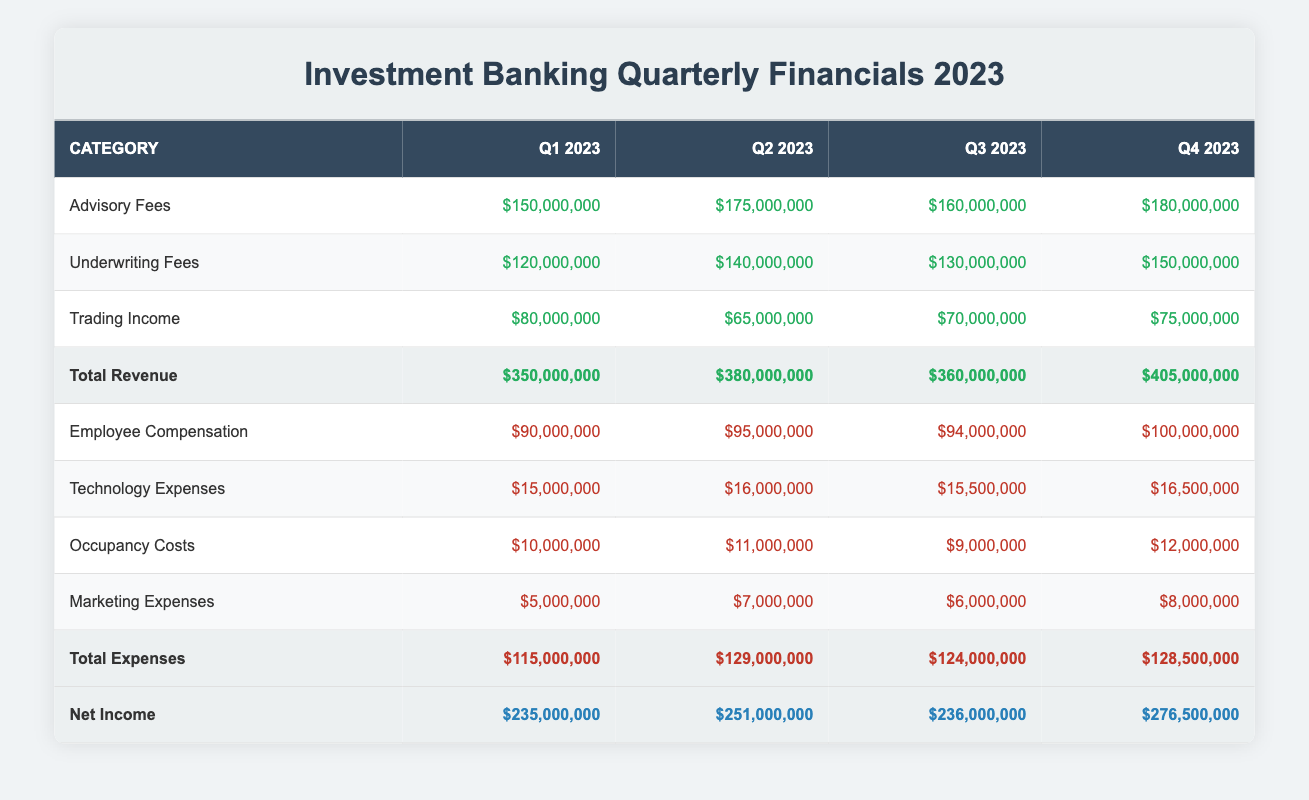What was the total revenue in Q3 2023? The table indicates that the total revenue for Q3 2023 is listed under "Total Revenue" in the row for Q3, which states $360,000,000.
Answer: $360,000,000 What are the employee compensation expenses for Q2 2023? Looking at the row for "Employee Compensation" in the Q2 column, it shows expenses of $95,000,000.
Answer: $95,000,000 Which quarter had the highest trading income, and what was that amount? The trading income amounts are indicated in the respective column for each quarter. Q2 had the lowest trading income of $65,000,000 while Q1 had $80,000,000, and Q4 had $75,000,000. So, the highest trading income of $80,000,000 was in Q1.
Answer: Q1, $80,000,000 What is the average net income across all quarters? The net income values for each quarter are $235,000,000 (Q1), $251,000,000 (Q2), $236,000,000 (Q3), and $276,500,000 (Q4). To find the average, add them: 235 + 251 + 236 + 276. This totals $998,000,000. Divide this by 4 (the number of quarters), which results in an average net income of $249,500,000.
Answer: $249,500,000 Is it true that total expenses increased every quarter? By inspecting the "Total Expenses" row for each quarter, the amounts are $115,000,000 (Q1), $129,000,000 (Q2), $124,000,000 (Q3), and $128,500,000 (Q4). Since the total expenses from Q2 to Q3 decreased, the statement is false.
Answer: False What was the increase in total revenue from Q1 to Q4? First, the total revenue in Q1 2023 is $350,000,000 and in Q4 2023 it is $405,000,000. To find the increase, subtract Q1 revenue from Q4 revenue: 405 - 350 = $55,000,000 increase.
Answer: $55,000,000 Which quarter observed the lowest total expenses, and what were those expenses? Checking the "Total Expenses" row, Q1 shows $115,000,000, Q2 shows $129,000,000, Q3 shows $124,000,000, and Q4 shows $128,500,000. Hence, Q1 had the lowest expenses at $115,000,000.
Answer: Q1, $115,000,000 What is the percentage increase in net income from Q2 to Q4? The net income for Q2 is $251,000,000 and for Q4 is $276,500,000. First, find the increase: 276.5 - 251 = $25,500,000. Then calculate the percentage increase using the formula: (increase / old value) * 100 = (25,500,000 / 251,000,000) * 100, which equals approximately 10.16%.
Answer: Approximately 10.16% 